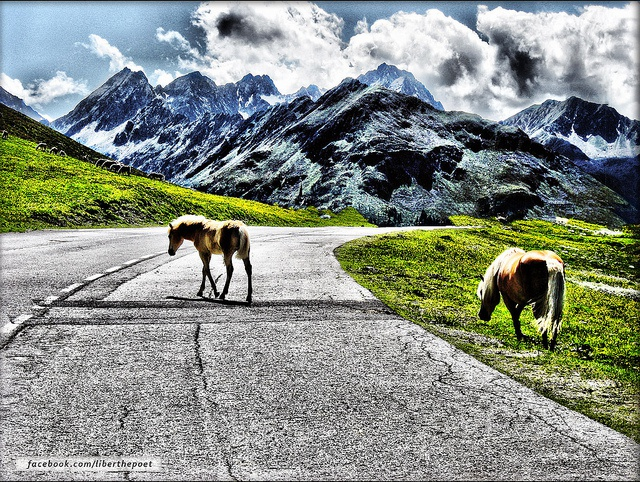Describe the objects in this image and their specific colors. I can see horse in black, ivory, khaki, and darkgreen tones and horse in black, ivory, maroon, and olive tones in this image. 